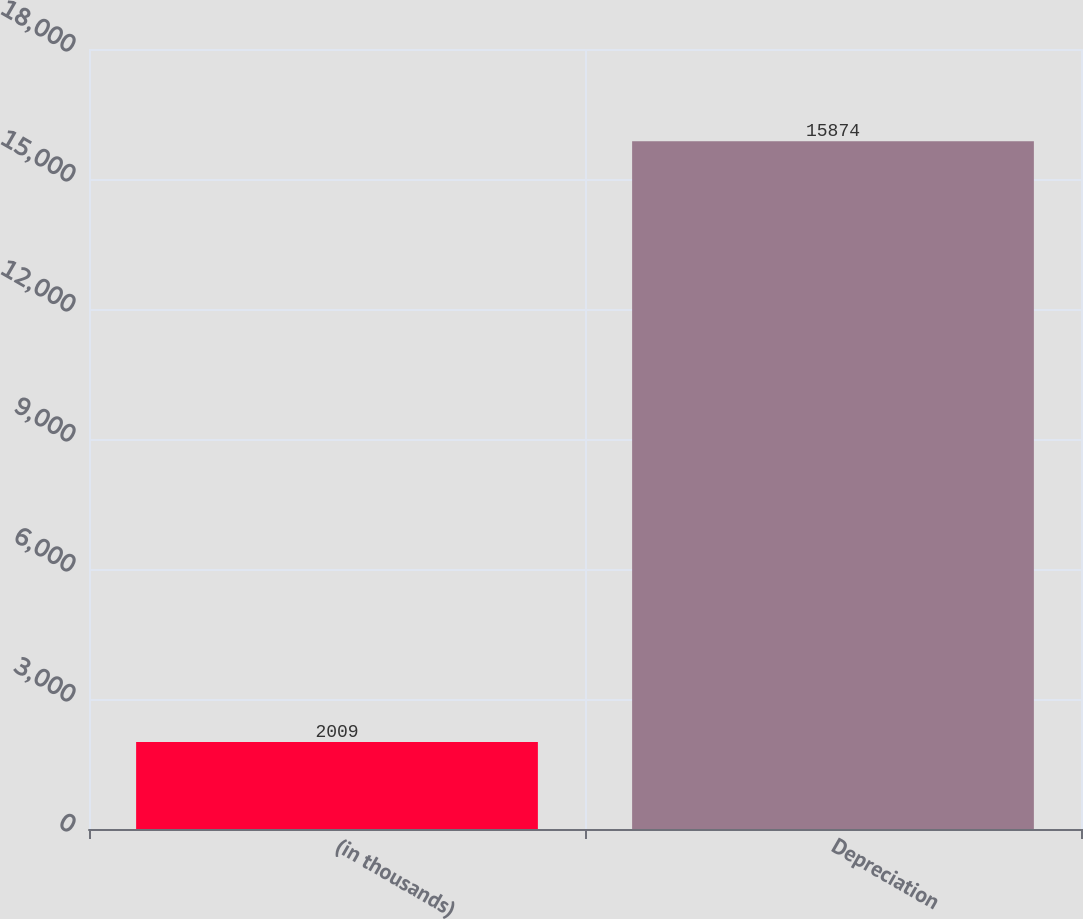Convert chart. <chart><loc_0><loc_0><loc_500><loc_500><bar_chart><fcel>(in thousands)<fcel>Depreciation<nl><fcel>2009<fcel>15874<nl></chart> 